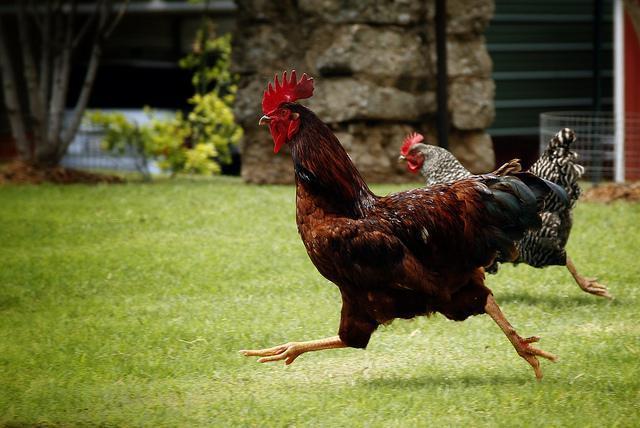How many chickens are there?
Give a very brief answer. 2. How many birds are there?
Give a very brief answer. 2. 